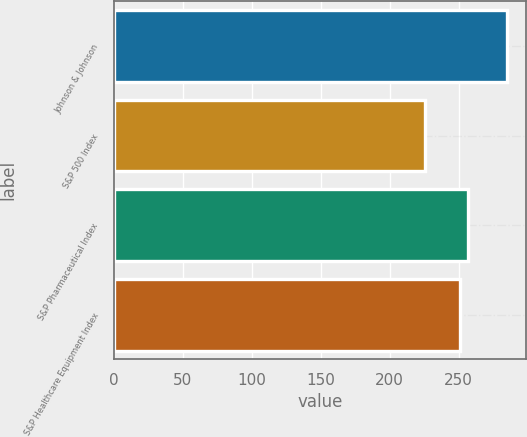<chart> <loc_0><loc_0><loc_500><loc_500><bar_chart><fcel>Johnson & Johnson<fcel>S&P 500 Index<fcel>S&P Pharmaceutical Index<fcel>S&P Healthcare Equipment Index<nl><fcel>284.85<fcel>225.85<fcel>257.1<fcel>251.2<nl></chart> 